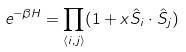Convert formula to latex. <formula><loc_0><loc_0><loc_500><loc_500>e ^ { - \beta H } = \prod _ { \langle i , j \rangle } ( 1 + x { \hat { S } _ { i } } \cdot { \hat { S } _ { j } } )</formula> 